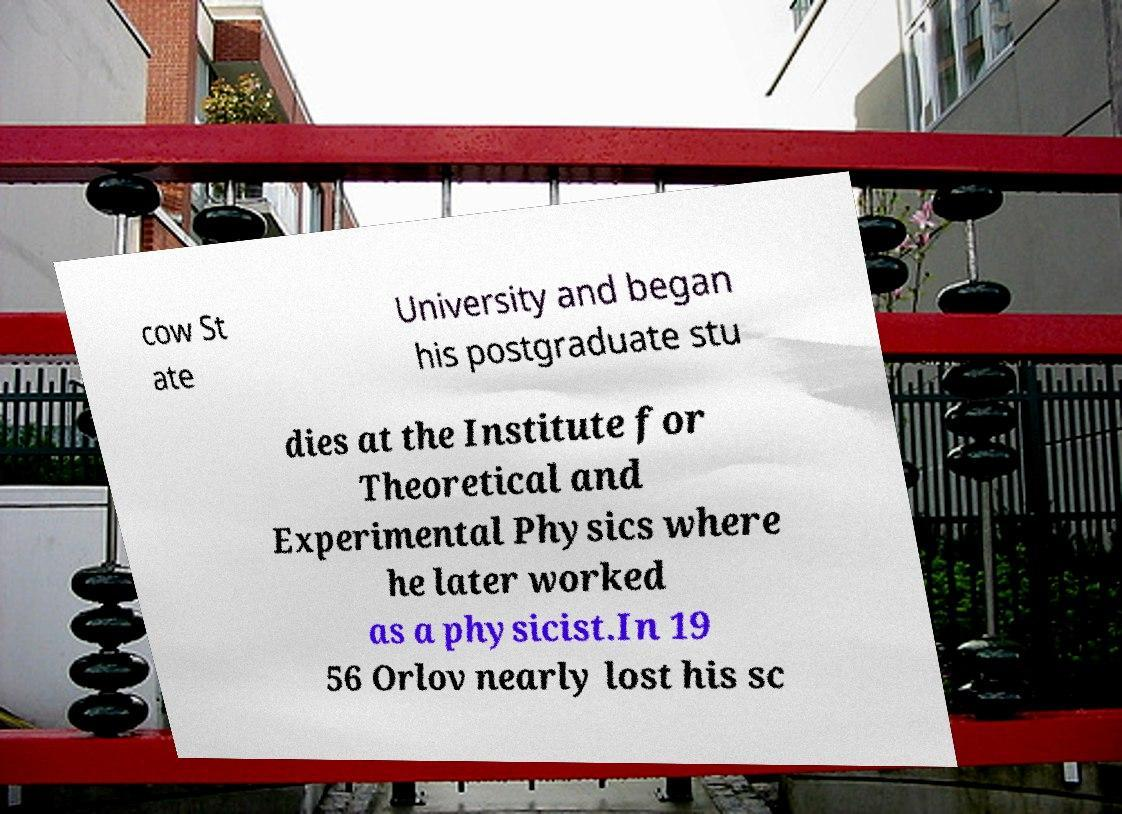For documentation purposes, I need the text within this image transcribed. Could you provide that? cow St ate University and began his postgraduate stu dies at the Institute for Theoretical and Experimental Physics where he later worked as a physicist.In 19 56 Orlov nearly lost his sc 